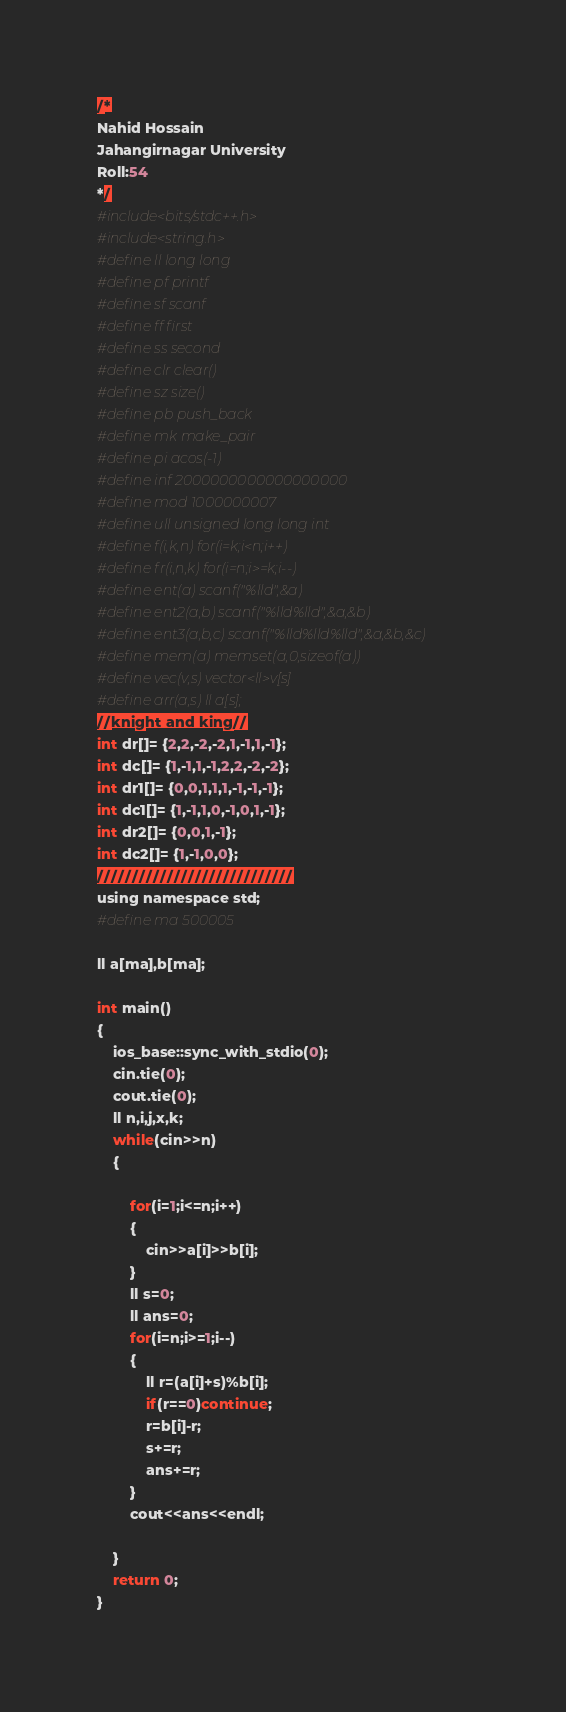<code> <loc_0><loc_0><loc_500><loc_500><_Awk_>/*
Nahid Hossain
Jahangirnagar University
Roll:54
*/
#include<bits/stdc++.h>
#include<string.h>
#define ll long long
#define pf printf
#define sf scanf
#define ff first
#define ss second
#define clr clear()
#define sz size()
#define pb push_back
#define mk make_pair
#define pi acos(-1)
#define inf 2000000000000000000
#define mod 1000000007
#define ull unsigned long long int
#define f(i,k,n) for(i=k;i<n;i++)
#define fr(i,n,k) for(i=n;i>=k;i--)
#define ent(a) scanf("%lld",&a)
#define ent2(a,b) scanf("%lld%lld",&a,&b)
#define ent3(a,b,c) scanf("%lld%lld%lld",&a,&b,&c)
#define mem(a) memset(a,0,sizeof(a))
#define vec(v,s) vector<ll>v[s]
#define arr(a,s) ll a[s];
//knight and king//
int dr[]= {2,2,-2,-2,1,-1,1,-1};
int dc[]= {1,-1,1,-1,2,2,-2,-2};
int dr1[]= {0,0,1,1,1,-1,-1,-1};
int dc1[]= {1,-1,1,0,-1,0,1,-1};
int dr2[]= {0,0,1,-1};
int dc2[]= {1,-1,0,0};
////////////////////////////
using namespace std;
#define ma 500005

ll a[ma],b[ma];

int main()
{
    ios_base::sync_with_stdio(0);
    cin.tie(0);
    cout.tie(0);
    ll n,i,j,x,k;
    while(cin>>n)
    {

        for(i=1;i<=n;i++)
        {
            cin>>a[i]>>b[i];
        }
        ll s=0;
        ll ans=0;
        for(i=n;i>=1;i--)
        {
            ll r=(a[i]+s)%b[i];
            if(r==0)continue;
            r=b[i]-r;
            s+=r;
            ans+=r;
        }
        cout<<ans<<endl;

    }
    return 0;
}
</code> 